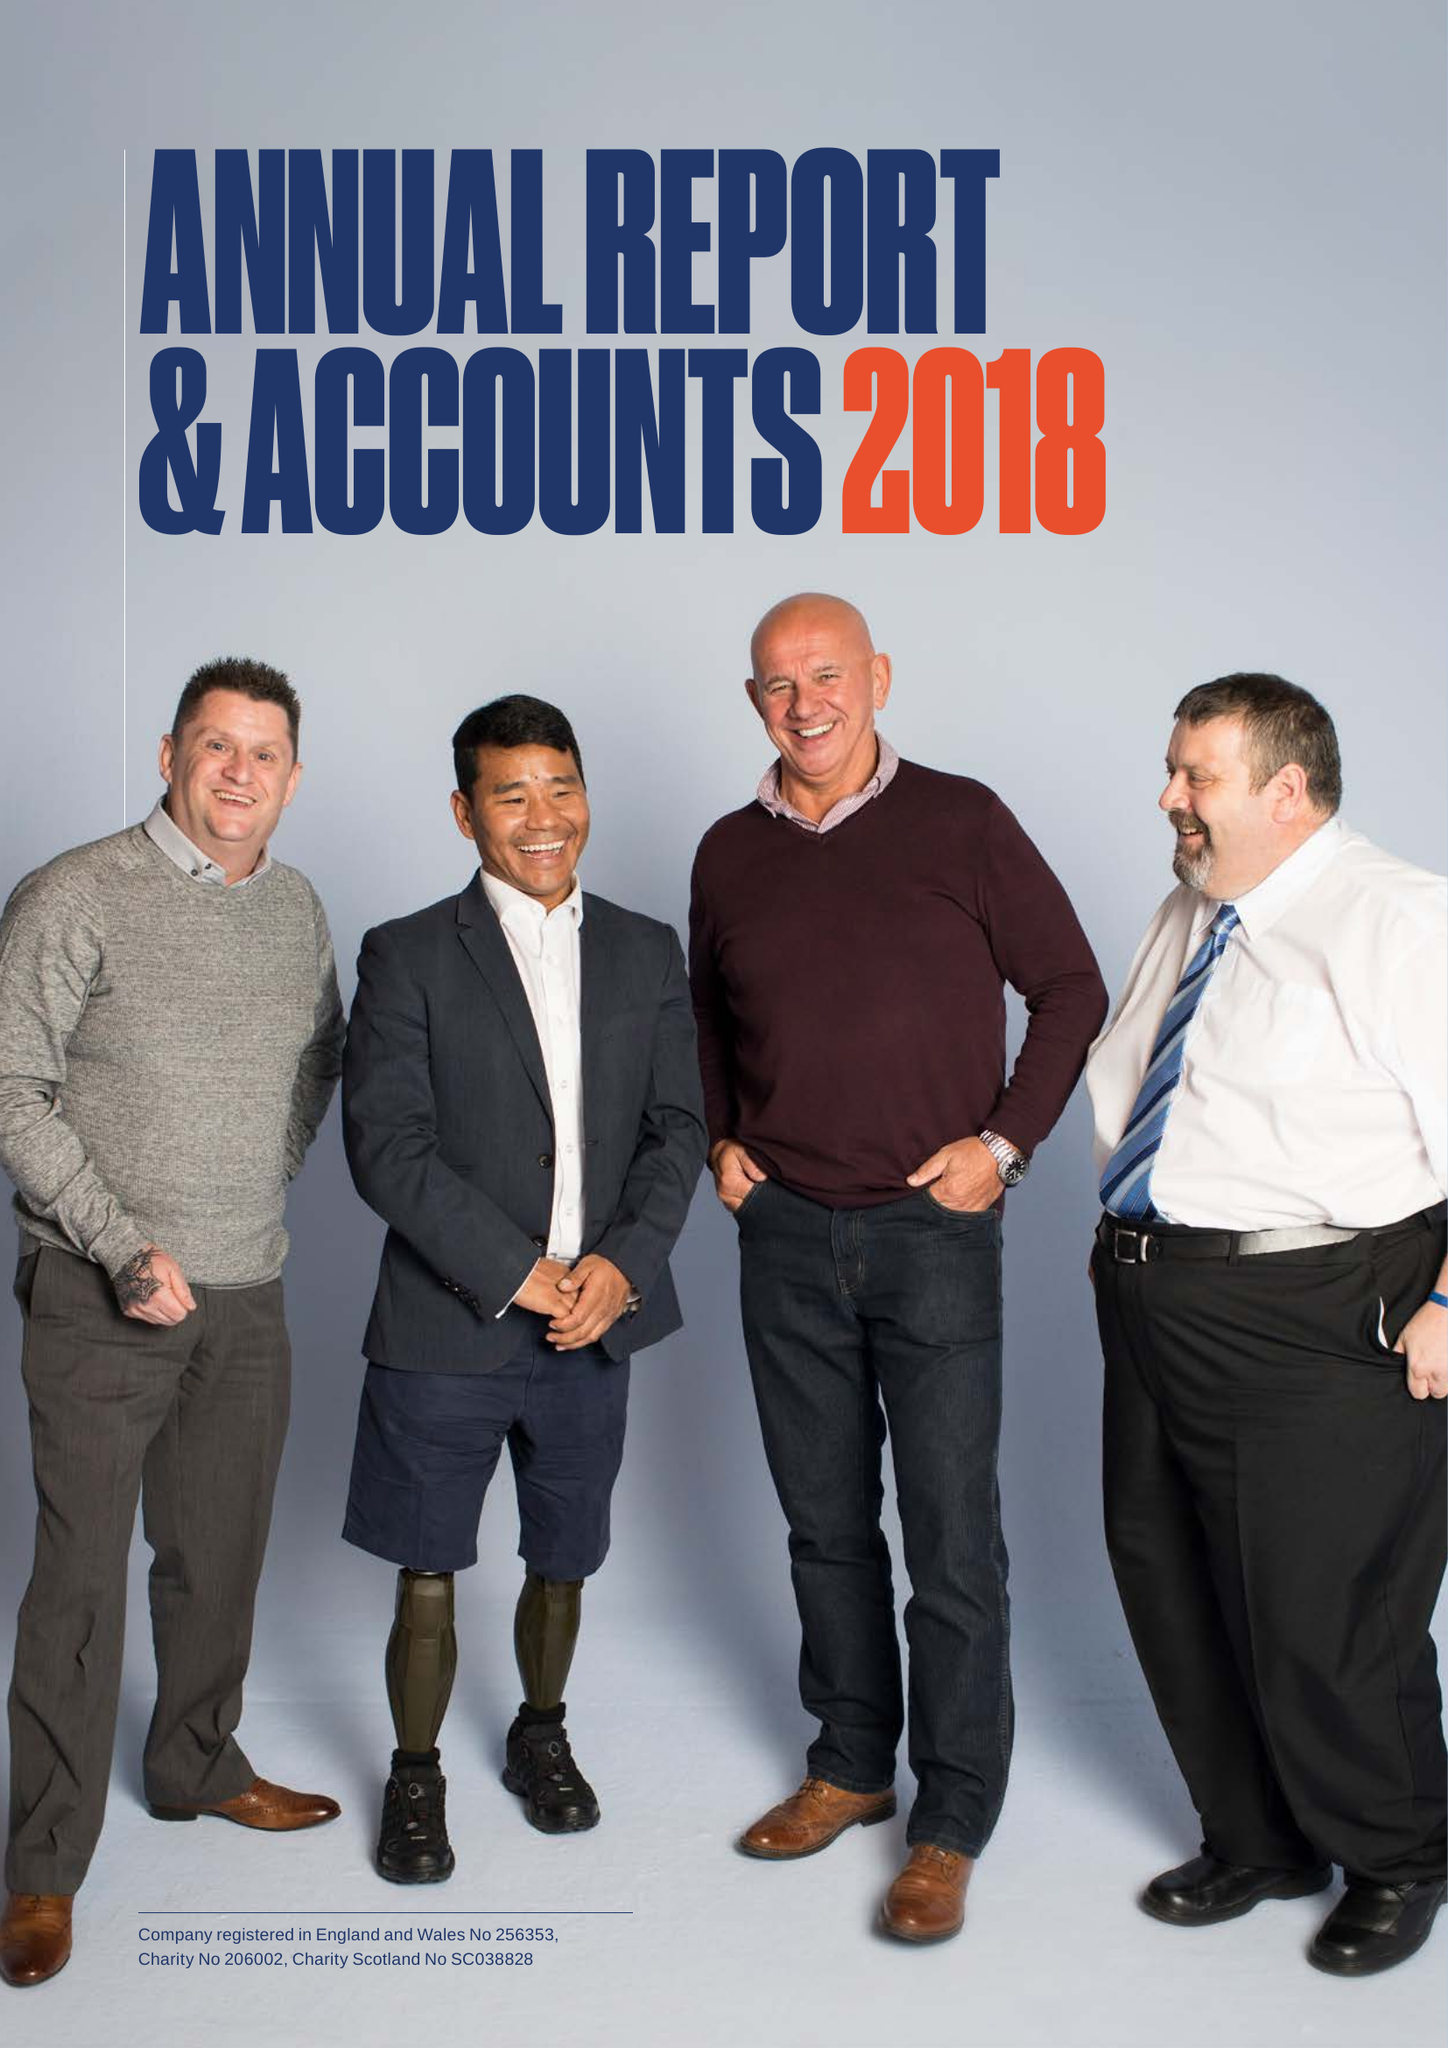What is the value for the address__postcode?
Answer the question using a single word or phrase. KT22 0BX 